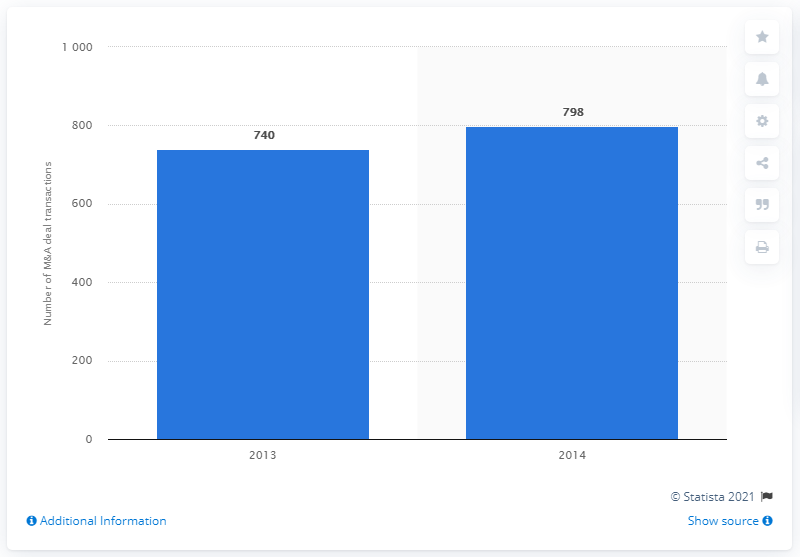What was the deal count in 2014? In 2014, the total number of mergers and acquisitions reached 798, indicating a significant increase from the previous year. 